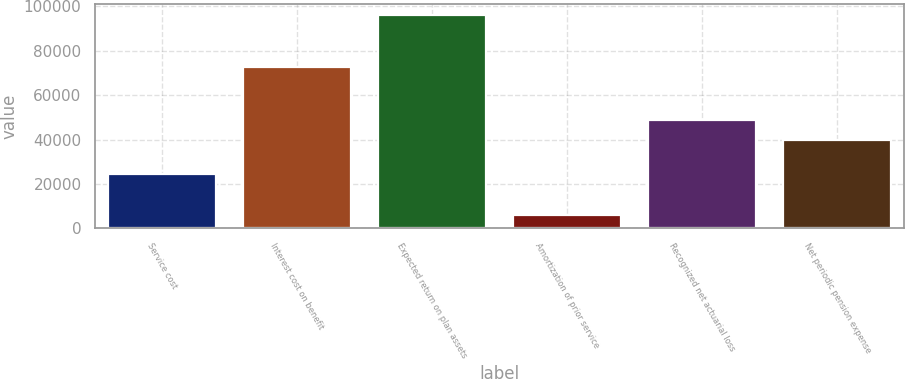Convert chart to OTSL. <chart><loc_0><loc_0><loc_500><loc_500><bar_chart><fcel>Service cost<fcel>Interest cost on benefit<fcel>Expected return on plan assets<fcel>Amortization of prior service<fcel>Recognized net actuarial loss<fcel>Net periodic pension expense<nl><fcel>24372<fcel>72731<fcel>96155<fcel>6005<fcel>48783<fcel>39768<nl></chart> 